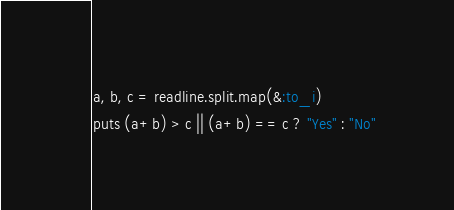<code> <loc_0><loc_0><loc_500><loc_500><_Ruby_>a, b, c = readline.split.map(&:to_i)
puts (a+b) > c || (a+b) == c ? "Yes" : "No"</code> 